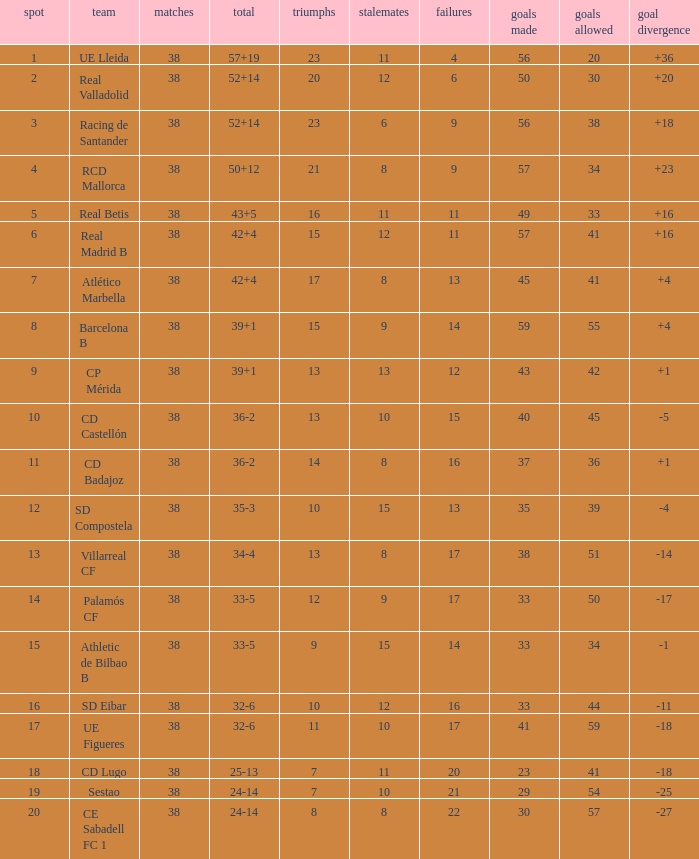What is the highest number played with a goal difference less than -27? None. 